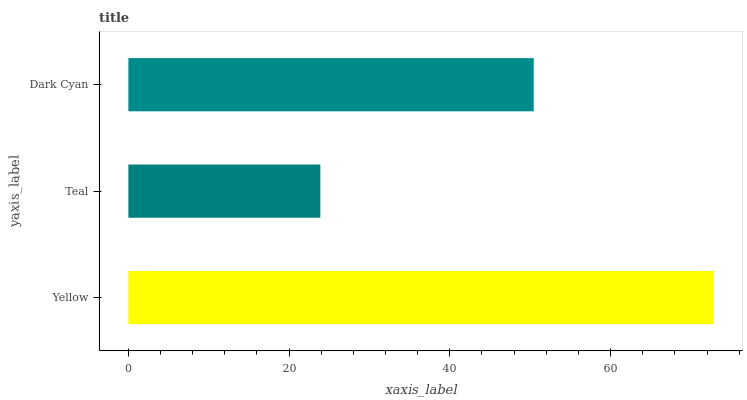Is Teal the minimum?
Answer yes or no. Yes. Is Yellow the maximum?
Answer yes or no. Yes. Is Dark Cyan the minimum?
Answer yes or no. No. Is Dark Cyan the maximum?
Answer yes or no. No. Is Dark Cyan greater than Teal?
Answer yes or no. Yes. Is Teal less than Dark Cyan?
Answer yes or no. Yes. Is Teal greater than Dark Cyan?
Answer yes or no. No. Is Dark Cyan less than Teal?
Answer yes or no. No. Is Dark Cyan the high median?
Answer yes or no. Yes. Is Dark Cyan the low median?
Answer yes or no. Yes. Is Teal the high median?
Answer yes or no. No. Is Teal the low median?
Answer yes or no. No. 